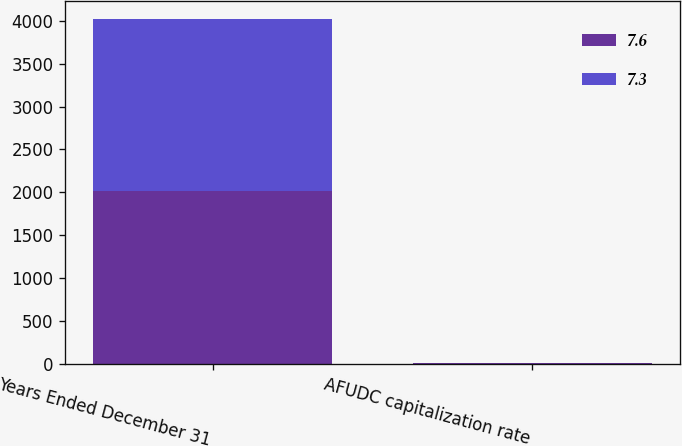Convert chart. <chart><loc_0><loc_0><loc_500><loc_500><stacked_bar_chart><ecel><fcel>Years Ended December 31<fcel>AFUDC capitalization rate<nl><fcel>7.6<fcel>2012<fcel>7.3<nl><fcel>7.3<fcel>2011<fcel>7.6<nl></chart> 